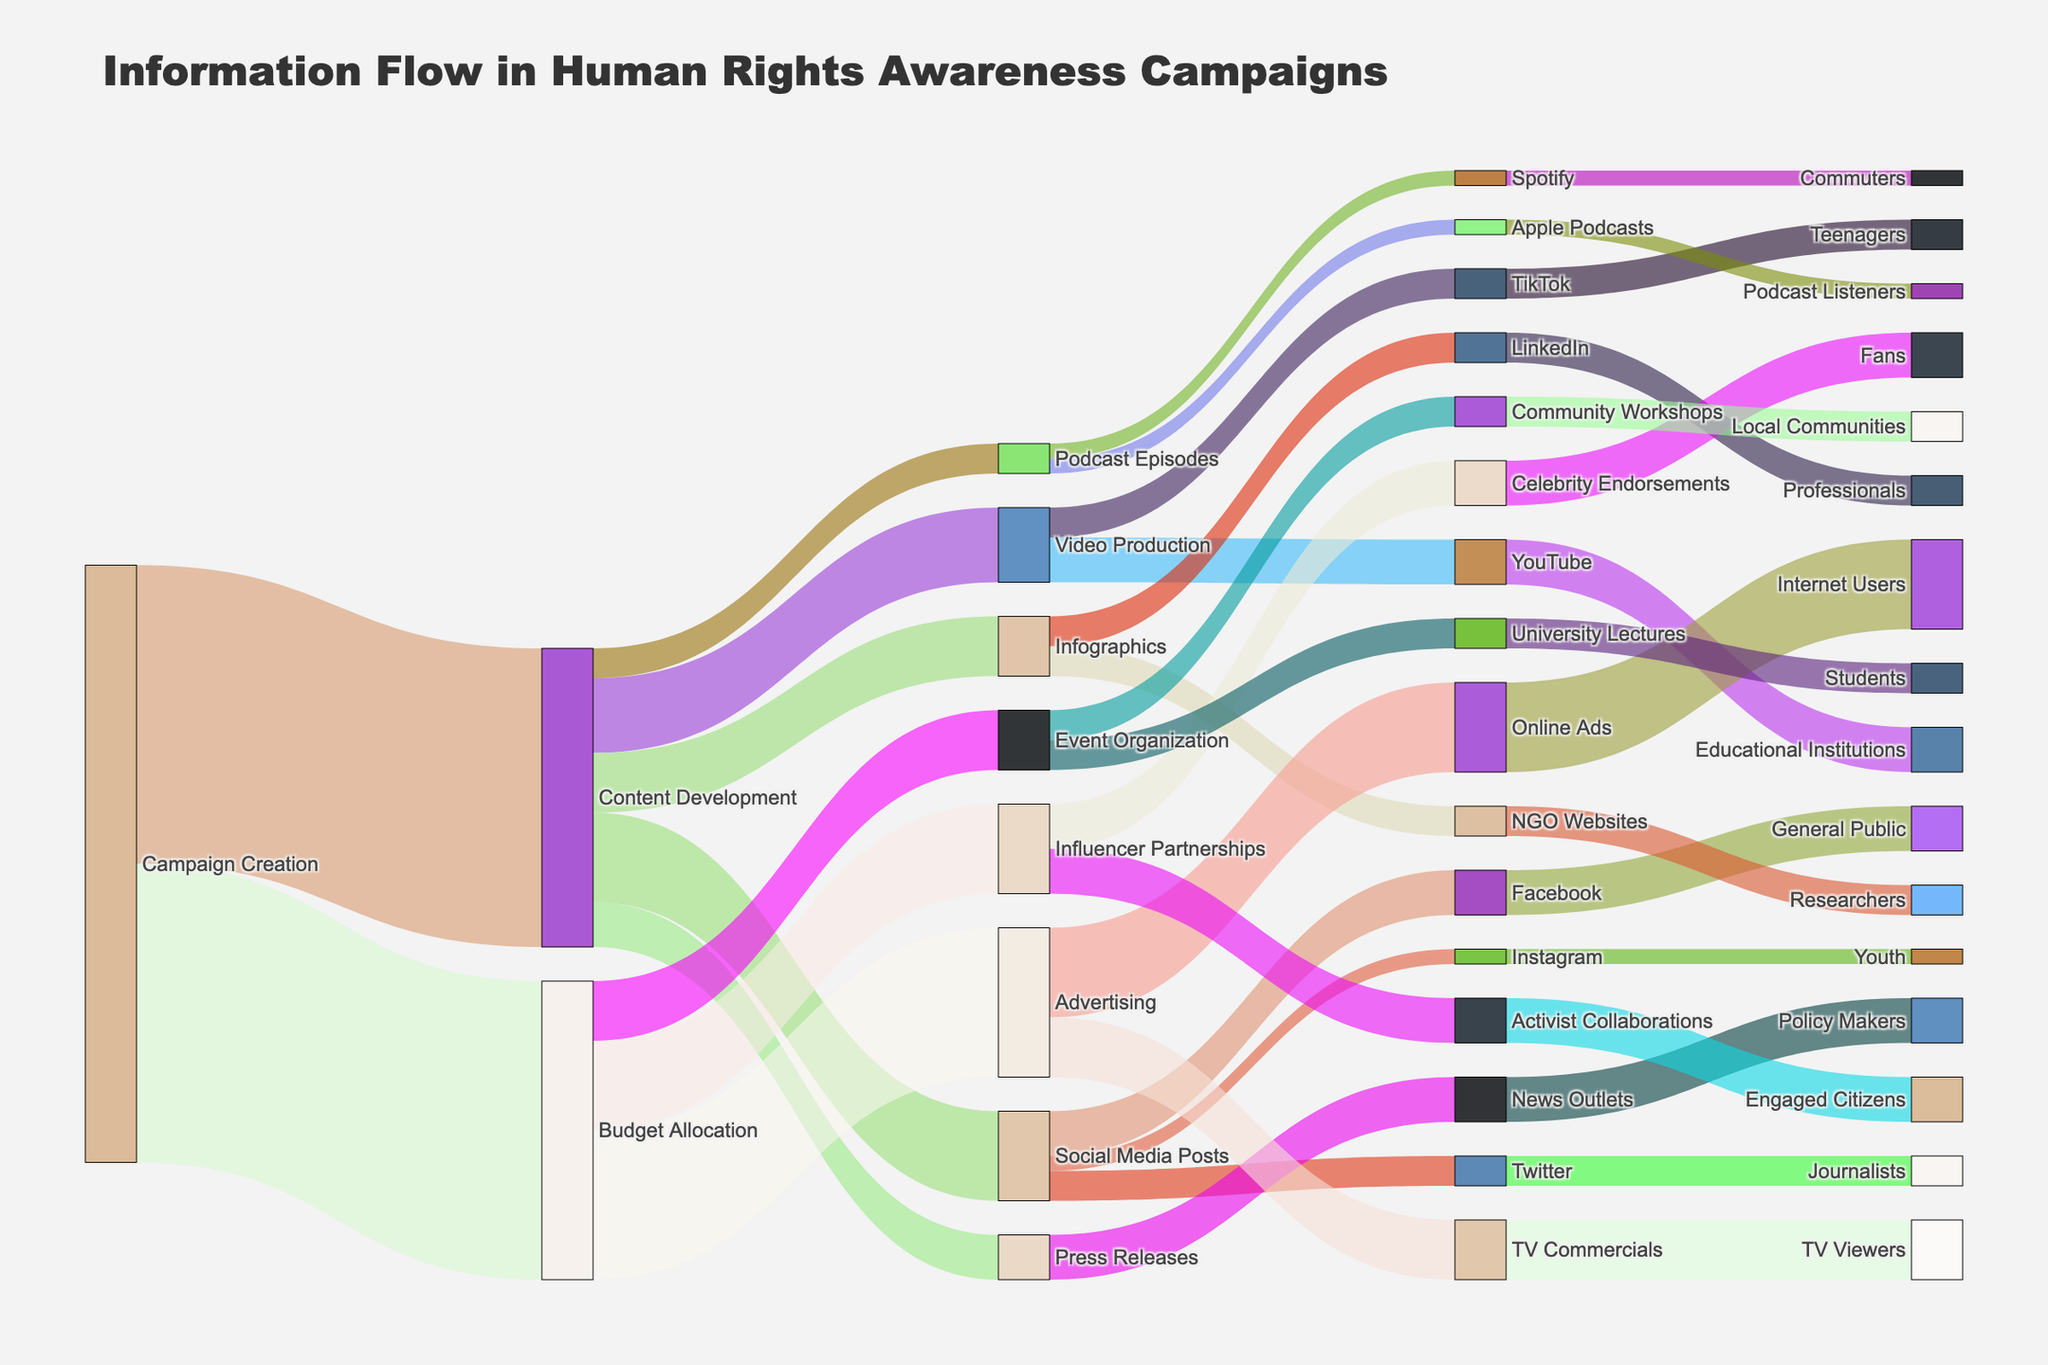What is the title of the Sankey diagram? The title of the diagram is prominently displayed at the top of the figure and summarizes the main topic being visualized.
Answer: Information Flow in Human Rights Awareness Campaigns How many total value units are allocated from Budget Allocation to Advertising? From the diagram, locate the link connecting Budget Allocation to Advertising, which indicates the value of this specific flow.
Answer: 50 Which target receives the smallest value from Social Media Posts? Check the links extending from Social Media Posts to its targets and identify the link with the smallest value.
Answer: Instagram What is the combined value allocated to Content Development and Budget Allocation from Campaign Creation? Sum the values from Campaign Creation to both Content Development and Budget Allocation by referring to the respective links.
Answer: 200 How does the value allocated to Event Organization compare with Influencer Partnerships? Compare the numerical values associated with the links from Budget Allocation to Event Organization and Influencer Partnerships.
Answer: Event Organization receives less than Influencer Partnerships Which platform receives more value from Video Production, YouTube or TikTok? Compare the values of the links from Video Production to both YouTube and TikTok.
Answer: YouTube What is the total value reaching the General Public through Social Media Posts? Follow the flow from Social Media Posts to Facebook, then to General Public and note the final value.
Answer: 15 Identify the audience that receives content via Podcasts. Trace the links from Podcast Episodes to its targets and then to the final audience.
Answer: Commuters and Podcast Listeners Which content format has the most varied distribution among platforms? Examine the different content formats and count the number of platforms each format is distributed among.
Answer: Content Development What is the total value of information reaching policy makers through the complete flow? Trace the flow from the source to the final target where policy makers are reached and sum up the values.
Answer: 15 